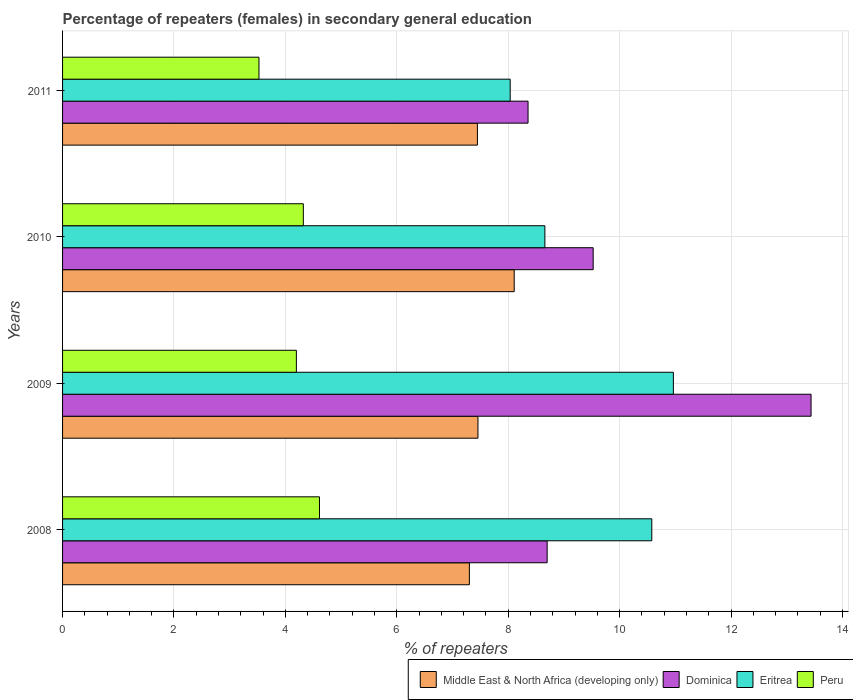How many groups of bars are there?
Provide a short and direct response. 4. How many bars are there on the 2nd tick from the top?
Your answer should be very brief. 4. In how many cases, is the number of bars for a given year not equal to the number of legend labels?
Provide a succinct answer. 0. What is the percentage of female repeaters in Dominica in 2009?
Offer a terse response. 13.43. Across all years, what is the maximum percentage of female repeaters in Dominica?
Give a very brief answer. 13.43. Across all years, what is the minimum percentage of female repeaters in Eritrea?
Your response must be concise. 8.03. In which year was the percentage of female repeaters in Peru maximum?
Your response must be concise. 2008. In which year was the percentage of female repeaters in Eritrea minimum?
Provide a short and direct response. 2011. What is the total percentage of female repeaters in Dominica in the graph?
Your answer should be compact. 40.01. What is the difference between the percentage of female repeaters in Middle East & North Africa (developing only) in 2010 and that in 2011?
Provide a short and direct response. 0.66. What is the difference between the percentage of female repeaters in Dominica in 2010 and the percentage of female repeaters in Eritrea in 2011?
Make the answer very short. 1.49. What is the average percentage of female repeaters in Dominica per year?
Provide a short and direct response. 10. In the year 2009, what is the difference between the percentage of female repeaters in Middle East & North Africa (developing only) and percentage of female repeaters in Dominica?
Your answer should be very brief. -5.98. What is the ratio of the percentage of female repeaters in Eritrea in 2009 to that in 2011?
Your answer should be compact. 1.36. Is the difference between the percentage of female repeaters in Middle East & North Africa (developing only) in 2008 and 2011 greater than the difference between the percentage of female repeaters in Dominica in 2008 and 2011?
Offer a terse response. No. What is the difference between the highest and the second highest percentage of female repeaters in Eritrea?
Your answer should be compact. 0.39. What is the difference between the highest and the lowest percentage of female repeaters in Dominica?
Your response must be concise. 5.08. In how many years, is the percentage of female repeaters in Dominica greater than the average percentage of female repeaters in Dominica taken over all years?
Make the answer very short. 1. What does the 4th bar from the top in 2011 represents?
Offer a very short reply. Middle East & North Africa (developing only). What does the 3rd bar from the bottom in 2011 represents?
Offer a very short reply. Eritrea. Does the graph contain any zero values?
Give a very brief answer. No. How are the legend labels stacked?
Keep it short and to the point. Horizontal. What is the title of the graph?
Provide a succinct answer. Percentage of repeaters (females) in secondary general education. Does "Djibouti" appear as one of the legend labels in the graph?
Offer a very short reply. No. What is the label or title of the X-axis?
Your response must be concise. % of repeaters. What is the label or title of the Y-axis?
Offer a terse response. Years. What is the % of repeaters in Middle East & North Africa (developing only) in 2008?
Provide a short and direct response. 7.3. What is the % of repeaters of Dominica in 2008?
Your response must be concise. 8.7. What is the % of repeaters of Eritrea in 2008?
Offer a terse response. 10.58. What is the % of repeaters in Peru in 2008?
Keep it short and to the point. 4.61. What is the % of repeaters in Middle East & North Africa (developing only) in 2009?
Offer a terse response. 7.46. What is the % of repeaters of Dominica in 2009?
Offer a very short reply. 13.43. What is the % of repeaters in Eritrea in 2009?
Your response must be concise. 10.96. What is the % of repeaters in Peru in 2009?
Provide a short and direct response. 4.2. What is the % of repeaters of Middle East & North Africa (developing only) in 2010?
Provide a short and direct response. 8.11. What is the % of repeaters of Dominica in 2010?
Your answer should be very brief. 9.52. What is the % of repeaters of Eritrea in 2010?
Offer a terse response. 8.66. What is the % of repeaters in Peru in 2010?
Provide a succinct answer. 4.32. What is the % of repeaters in Middle East & North Africa (developing only) in 2011?
Make the answer very short. 7.45. What is the % of repeaters in Dominica in 2011?
Provide a succinct answer. 8.36. What is the % of repeaters of Eritrea in 2011?
Offer a terse response. 8.03. What is the % of repeaters of Peru in 2011?
Provide a succinct answer. 3.53. Across all years, what is the maximum % of repeaters of Middle East & North Africa (developing only)?
Provide a succinct answer. 8.11. Across all years, what is the maximum % of repeaters in Dominica?
Your response must be concise. 13.43. Across all years, what is the maximum % of repeaters in Eritrea?
Ensure brevity in your answer.  10.96. Across all years, what is the maximum % of repeaters in Peru?
Offer a very short reply. 4.61. Across all years, what is the minimum % of repeaters of Middle East & North Africa (developing only)?
Your answer should be compact. 7.3. Across all years, what is the minimum % of repeaters in Dominica?
Offer a very short reply. 8.36. Across all years, what is the minimum % of repeaters in Eritrea?
Give a very brief answer. 8.03. Across all years, what is the minimum % of repeaters in Peru?
Make the answer very short. 3.53. What is the total % of repeaters in Middle East & North Africa (developing only) in the graph?
Offer a very short reply. 30.31. What is the total % of repeaters of Dominica in the graph?
Your answer should be very brief. 40.01. What is the total % of repeaters in Eritrea in the graph?
Make the answer very short. 38.23. What is the total % of repeaters in Peru in the graph?
Provide a short and direct response. 16.65. What is the difference between the % of repeaters in Middle East & North Africa (developing only) in 2008 and that in 2009?
Provide a short and direct response. -0.15. What is the difference between the % of repeaters in Dominica in 2008 and that in 2009?
Your answer should be compact. -4.74. What is the difference between the % of repeaters of Eritrea in 2008 and that in 2009?
Your answer should be very brief. -0.39. What is the difference between the % of repeaters in Peru in 2008 and that in 2009?
Keep it short and to the point. 0.41. What is the difference between the % of repeaters in Middle East & North Africa (developing only) in 2008 and that in 2010?
Make the answer very short. -0.8. What is the difference between the % of repeaters of Dominica in 2008 and that in 2010?
Offer a very short reply. -0.83. What is the difference between the % of repeaters in Eritrea in 2008 and that in 2010?
Make the answer very short. 1.92. What is the difference between the % of repeaters in Peru in 2008 and that in 2010?
Make the answer very short. 0.29. What is the difference between the % of repeaters in Middle East & North Africa (developing only) in 2008 and that in 2011?
Give a very brief answer. -0.14. What is the difference between the % of repeaters of Dominica in 2008 and that in 2011?
Your response must be concise. 0.34. What is the difference between the % of repeaters in Eritrea in 2008 and that in 2011?
Make the answer very short. 2.54. What is the difference between the % of repeaters in Peru in 2008 and that in 2011?
Give a very brief answer. 1.09. What is the difference between the % of repeaters in Middle East & North Africa (developing only) in 2009 and that in 2010?
Keep it short and to the point. -0.65. What is the difference between the % of repeaters of Dominica in 2009 and that in 2010?
Ensure brevity in your answer.  3.91. What is the difference between the % of repeaters of Eritrea in 2009 and that in 2010?
Ensure brevity in your answer.  2.31. What is the difference between the % of repeaters in Peru in 2009 and that in 2010?
Offer a very short reply. -0.12. What is the difference between the % of repeaters in Middle East & North Africa (developing only) in 2009 and that in 2011?
Your answer should be compact. 0.01. What is the difference between the % of repeaters in Dominica in 2009 and that in 2011?
Ensure brevity in your answer.  5.08. What is the difference between the % of repeaters of Eritrea in 2009 and that in 2011?
Offer a terse response. 2.93. What is the difference between the % of repeaters of Peru in 2009 and that in 2011?
Your answer should be very brief. 0.67. What is the difference between the % of repeaters of Middle East & North Africa (developing only) in 2010 and that in 2011?
Your answer should be compact. 0.66. What is the difference between the % of repeaters in Dominica in 2010 and that in 2011?
Your response must be concise. 1.17. What is the difference between the % of repeaters of Eritrea in 2010 and that in 2011?
Give a very brief answer. 0.62. What is the difference between the % of repeaters in Peru in 2010 and that in 2011?
Give a very brief answer. 0.8. What is the difference between the % of repeaters of Middle East & North Africa (developing only) in 2008 and the % of repeaters of Dominica in 2009?
Offer a very short reply. -6.13. What is the difference between the % of repeaters in Middle East & North Africa (developing only) in 2008 and the % of repeaters in Eritrea in 2009?
Keep it short and to the point. -3.66. What is the difference between the % of repeaters in Middle East & North Africa (developing only) in 2008 and the % of repeaters in Peru in 2009?
Your response must be concise. 3.11. What is the difference between the % of repeaters in Dominica in 2008 and the % of repeaters in Eritrea in 2009?
Your answer should be compact. -2.27. What is the difference between the % of repeaters of Dominica in 2008 and the % of repeaters of Peru in 2009?
Your answer should be very brief. 4.5. What is the difference between the % of repeaters of Eritrea in 2008 and the % of repeaters of Peru in 2009?
Provide a succinct answer. 6.38. What is the difference between the % of repeaters in Middle East & North Africa (developing only) in 2008 and the % of repeaters in Dominica in 2010?
Your answer should be compact. -2.22. What is the difference between the % of repeaters of Middle East & North Africa (developing only) in 2008 and the % of repeaters of Eritrea in 2010?
Ensure brevity in your answer.  -1.36. What is the difference between the % of repeaters of Middle East & North Africa (developing only) in 2008 and the % of repeaters of Peru in 2010?
Your answer should be very brief. 2.98. What is the difference between the % of repeaters of Dominica in 2008 and the % of repeaters of Eritrea in 2010?
Your answer should be very brief. 0.04. What is the difference between the % of repeaters of Dominica in 2008 and the % of repeaters of Peru in 2010?
Keep it short and to the point. 4.38. What is the difference between the % of repeaters in Eritrea in 2008 and the % of repeaters in Peru in 2010?
Give a very brief answer. 6.25. What is the difference between the % of repeaters of Middle East & North Africa (developing only) in 2008 and the % of repeaters of Dominica in 2011?
Ensure brevity in your answer.  -1.05. What is the difference between the % of repeaters in Middle East & North Africa (developing only) in 2008 and the % of repeaters in Eritrea in 2011?
Make the answer very short. -0.73. What is the difference between the % of repeaters of Middle East & North Africa (developing only) in 2008 and the % of repeaters of Peru in 2011?
Your response must be concise. 3.78. What is the difference between the % of repeaters in Dominica in 2008 and the % of repeaters in Eritrea in 2011?
Your answer should be compact. 0.66. What is the difference between the % of repeaters of Dominica in 2008 and the % of repeaters of Peru in 2011?
Your response must be concise. 5.17. What is the difference between the % of repeaters of Eritrea in 2008 and the % of repeaters of Peru in 2011?
Give a very brief answer. 7.05. What is the difference between the % of repeaters in Middle East & North Africa (developing only) in 2009 and the % of repeaters in Dominica in 2010?
Give a very brief answer. -2.07. What is the difference between the % of repeaters of Middle East & North Africa (developing only) in 2009 and the % of repeaters of Eritrea in 2010?
Provide a succinct answer. -1.2. What is the difference between the % of repeaters in Middle East & North Africa (developing only) in 2009 and the % of repeaters in Peru in 2010?
Offer a terse response. 3.13. What is the difference between the % of repeaters in Dominica in 2009 and the % of repeaters in Eritrea in 2010?
Your response must be concise. 4.78. What is the difference between the % of repeaters in Dominica in 2009 and the % of repeaters in Peru in 2010?
Provide a succinct answer. 9.11. What is the difference between the % of repeaters of Eritrea in 2009 and the % of repeaters of Peru in 2010?
Ensure brevity in your answer.  6.64. What is the difference between the % of repeaters in Middle East & North Africa (developing only) in 2009 and the % of repeaters in Dominica in 2011?
Ensure brevity in your answer.  -0.9. What is the difference between the % of repeaters in Middle East & North Africa (developing only) in 2009 and the % of repeaters in Eritrea in 2011?
Provide a succinct answer. -0.58. What is the difference between the % of repeaters in Middle East & North Africa (developing only) in 2009 and the % of repeaters in Peru in 2011?
Ensure brevity in your answer.  3.93. What is the difference between the % of repeaters of Dominica in 2009 and the % of repeaters of Eritrea in 2011?
Provide a succinct answer. 5.4. What is the difference between the % of repeaters in Dominica in 2009 and the % of repeaters in Peru in 2011?
Provide a succinct answer. 9.91. What is the difference between the % of repeaters of Eritrea in 2009 and the % of repeaters of Peru in 2011?
Your answer should be very brief. 7.44. What is the difference between the % of repeaters in Middle East & North Africa (developing only) in 2010 and the % of repeaters in Dominica in 2011?
Your answer should be very brief. -0.25. What is the difference between the % of repeaters of Middle East & North Africa (developing only) in 2010 and the % of repeaters of Eritrea in 2011?
Your answer should be compact. 0.07. What is the difference between the % of repeaters in Middle East & North Africa (developing only) in 2010 and the % of repeaters in Peru in 2011?
Your answer should be very brief. 4.58. What is the difference between the % of repeaters of Dominica in 2010 and the % of repeaters of Eritrea in 2011?
Give a very brief answer. 1.49. What is the difference between the % of repeaters of Dominica in 2010 and the % of repeaters of Peru in 2011?
Offer a terse response. 6. What is the difference between the % of repeaters of Eritrea in 2010 and the % of repeaters of Peru in 2011?
Make the answer very short. 5.13. What is the average % of repeaters of Middle East & North Africa (developing only) per year?
Provide a succinct answer. 7.58. What is the average % of repeaters in Dominica per year?
Provide a short and direct response. 10. What is the average % of repeaters in Eritrea per year?
Give a very brief answer. 9.56. What is the average % of repeaters in Peru per year?
Your response must be concise. 4.16. In the year 2008, what is the difference between the % of repeaters in Middle East & North Africa (developing only) and % of repeaters in Dominica?
Your answer should be compact. -1.4. In the year 2008, what is the difference between the % of repeaters of Middle East & North Africa (developing only) and % of repeaters of Eritrea?
Offer a very short reply. -3.27. In the year 2008, what is the difference between the % of repeaters of Middle East & North Africa (developing only) and % of repeaters of Peru?
Offer a very short reply. 2.69. In the year 2008, what is the difference between the % of repeaters of Dominica and % of repeaters of Eritrea?
Ensure brevity in your answer.  -1.88. In the year 2008, what is the difference between the % of repeaters in Dominica and % of repeaters in Peru?
Provide a short and direct response. 4.09. In the year 2008, what is the difference between the % of repeaters of Eritrea and % of repeaters of Peru?
Make the answer very short. 5.96. In the year 2009, what is the difference between the % of repeaters in Middle East & North Africa (developing only) and % of repeaters in Dominica?
Offer a very short reply. -5.98. In the year 2009, what is the difference between the % of repeaters in Middle East & North Africa (developing only) and % of repeaters in Eritrea?
Offer a terse response. -3.51. In the year 2009, what is the difference between the % of repeaters in Middle East & North Africa (developing only) and % of repeaters in Peru?
Offer a very short reply. 3.26. In the year 2009, what is the difference between the % of repeaters of Dominica and % of repeaters of Eritrea?
Your answer should be compact. 2.47. In the year 2009, what is the difference between the % of repeaters of Dominica and % of repeaters of Peru?
Give a very brief answer. 9.24. In the year 2009, what is the difference between the % of repeaters in Eritrea and % of repeaters in Peru?
Offer a terse response. 6.77. In the year 2010, what is the difference between the % of repeaters in Middle East & North Africa (developing only) and % of repeaters in Dominica?
Keep it short and to the point. -1.42. In the year 2010, what is the difference between the % of repeaters in Middle East & North Africa (developing only) and % of repeaters in Eritrea?
Provide a short and direct response. -0.55. In the year 2010, what is the difference between the % of repeaters in Middle East & North Africa (developing only) and % of repeaters in Peru?
Ensure brevity in your answer.  3.79. In the year 2010, what is the difference between the % of repeaters of Dominica and % of repeaters of Eritrea?
Make the answer very short. 0.87. In the year 2010, what is the difference between the % of repeaters of Dominica and % of repeaters of Peru?
Your response must be concise. 5.2. In the year 2010, what is the difference between the % of repeaters of Eritrea and % of repeaters of Peru?
Give a very brief answer. 4.34. In the year 2011, what is the difference between the % of repeaters in Middle East & North Africa (developing only) and % of repeaters in Dominica?
Your response must be concise. -0.91. In the year 2011, what is the difference between the % of repeaters of Middle East & North Africa (developing only) and % of repeaters of Eritrea?
Ensure brevity in your answer.  -0.59. In the year 2011, what is the difference between the % of repeaters of Middle East & North Africa (developing only) and % of repeaters of Peru?
Provide a succinct answer. 3.92. In the year 2011, what is the difference between the % of repeaters of Dominica and % of repeaters of Eritrea?
Provide a succinct answer. 0.32. In the year 2011, what is the difference between the % of repeaters of Dominica and % of repeaters of Peru?
Your answer should be compact. 4.83. In the year 2011, what is the difference between the % of repeaters in Eritrea and % of repeaters in Peru?
Provide a short and direct response. 4.51. What is the ratio of the % of repeaters of Middle East & North Africa (developing only) in 2008 to that in 2009?
Provide a succinct answer. 0.98. What is the ratio of the % of repeaters of Dominica in 2008 to that in 2009?
Your answer should be compact. 0.65. What is the ratio of the % of repeaters of Eritrea in 2008 to that in 2009?
Offer a very short reply. 0.96. What is the ratio of the % of repeaters of Peru in 2008 to that in 2009?
Offer a terse response. 1.1. What is the ratio of the % of repeaters of Middle East & North Africa (developing only) in 2008 to that in 2010?
Your response must be concise. 0.9. What is the ratio of the % of repeaters of Dominica in 2008 to that in 2010?
Your answer should be compact. 0.91. What is the ratio of the % of repeaters of Eritrea in 2008 to that in 2010?
Your answer should be compact. 1.22. What is the ratio of the % of repeaters of Peru in 2008 to that in 2010?
Provide a succinct answer. 1.07. What is the ratio of the % of repeaters in Middle East & North Africa (developing only) in 2008 to that in 2011?
Offer a terse response. 0.98. What is the ratio of the % of repeaters of Dominica in 2008 to that in 2011?
Offer a terse response. 1.04. What is the ratio of the % of repeaters of Eritrea in 2008 to that in 2011?
Provide a short and direct response. 1.32. What is the ratio of the % of repeaters of Peru in 2008 to that in 2011?
Your answer should be very brief. 1.31. What is the ratio of the % of repeaters of Middle East & North Africa (developing only) in 2009 to that in 2010?
Your answer should be very brief. 0.92. What is the ratio of the % of repeaters in Dominica in 2009 to that in 2010?
Provide a short and direct response. 1.41. What is the ratio of the % of repeaters of Eritrea in 2009 to that in 2010?
Your response must be concise. 1.27. What is the ratio of the % of repeaters in Peru in 2009 to that in 2010?
Give a very brief answer. 0.97. What is the ratio of the % of repeaters in Middle East & North Africa (developing only) in 2009 to that in 2011?
Offer a terse response. 1. What is the ratio of the % of repeaters of Dominica in 2009 to that in 2011?
Provide a short and direct response. 1.61. What is the ratio of the % of repeaters in Eritrea in 2009 to that in 2011?
Offer a terse response. 1.36. What is the ratio of the % of repeaters of Peru in 2009 to that in 2011?
Provide a succinct answer. 1.19. What is the ratio of the % of repeaters of Middle East & North Africa (developing only) in 2010 to that in 2011?
Provide a short and direct response. 1.09. What is the ratio of the % of repeaters in Dominica in 2010 to that in 2011?
Offer a very short reply. 1.14. What is the ratio of the % of repeaters in Eritrea in 2010 to that in 2011?
Provide a short and direct response. 1.08. What is the ratio of the % of repeaters of Peru in 2010 to that in 2011?
Offer a terse response. 1.23. What is the difference between the highest and the second highest % of repeaters of Middle East & North Africa (developing only)?
Your answer should be compact. 0.65. What is the difference between the highest and the second highest % of repeaters of Dominica?
Offer a very short reply. 3.91. What is the difference between the highest and the second highest % of repeaters of Eritrea?
Provide a short and direct response. 0.39. What is the difference between the highest and the second highest % of repeaters in Peru?
Your answer should be very brief. 0.29. What is the difference between the highest and the lowest % of repeaters of Middle East & North Africa (developing only)?
Your response must be concise. 0.8. What is the difference between the highest and the lowest % of repeaters of Dominica?
Provide a short and direct response. 5.08. What is the difference between the highest and the lowest % of repeaters of Eritrea?
Keep it short and to the point. 2.93. What is the difference between the highest and the lowest % of repeaters of Peru?
Offer a terse response. 1.09. 